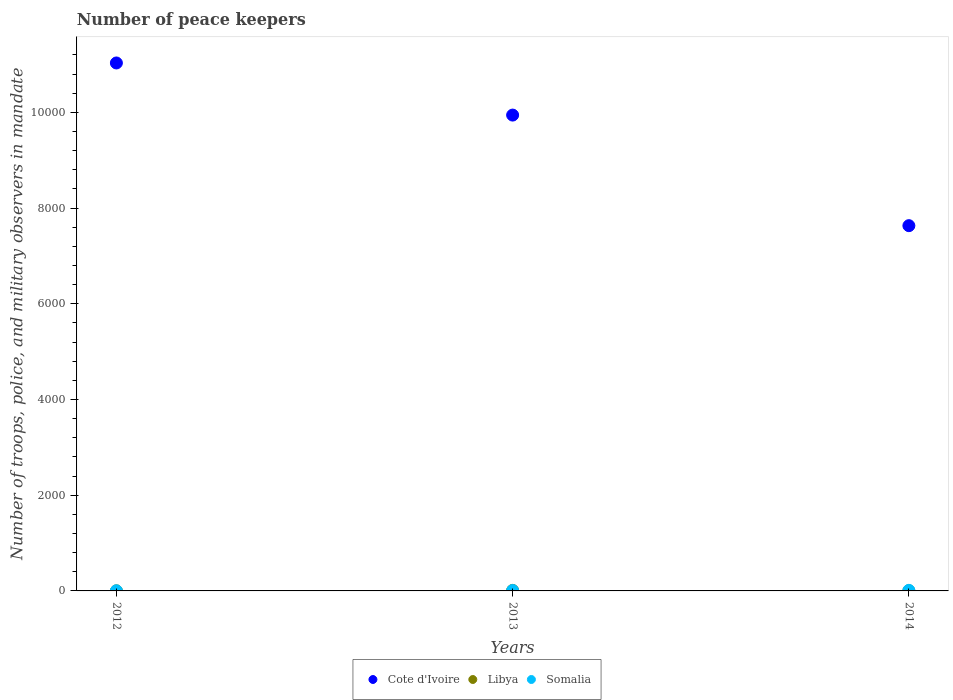Is the number of dotlines equal to the number of legend labels?
Give a very brief answer. Yes. What is the number of peace keepers in in Cote d'Ivoire in 2014?
Make the answer very short. 7633. Across all years, what is the maximum number of peace keepers in in Libya?
Provide a succinct answer. 11. What is the total number of peace keepers in in Cote d'Ivoire in the graph?
Provide a succinct answer. 2.86e+04. What is the difference between the number of peace keepers in in Somalia in 2013 and the number of peace keepers in in Cote d'Ivoire in 2012?
Provide a succinct answer. -1.10e+04. What is the average number of peace keepers in in Libya per year?
Your response must be concise. 5. In how many years, is the number of peace keepers in in Somalia greater than 10000?
Offer a very short reply. 0. Is the number of peace keepers in in Somalia in 2012 less than that in 2014?
Ensure brevity in your answer.  Yes. What is the difference between the highest and the second highest number of peace keepers in in Cote d'Ivoire?
Give a very brief answer. 1089. What is the difference between the highest and the lowest number of peace keepers in in Cote d'Ivoire?
Provide a short and direct response. 3400. Is the sum of the number of peace keepers in in Somalia in 2013 and 2014 greater than the maximum number of peace keepers in in Cote d'Ivoire across all years?
Your answer should be very brief. No. Is the number of peace keepers in in Cote d'Ivoire strictly greater than the number of peace keepers in in Libya over the years?
Offer a very short reply. Yes. Is the number of peace keepers in in Somalia strictly less than the number of peace keepers in in Cote d'Ivoire over the years?
Provide a short and direct response. Yes. How many dotlines are there?
Offer a terse response. 3. How many legend labels are there?
Your answer should be compact. 3. How are the legend labels stacked?
Offer a very short reply. Horizontal. What is the title of the graph?
Provide a short and direct response. Number of peace keepers. Does "Euro area" appear as one of the legend labels in the graph?
Offer a terse response. No. What is the label or title of the Y-axis?
Your answer should be very brief. Number of troops, police, and military observers in mandate. What is the Number of troops, police, and military observers in mandate of Cote d'Ivoire in 2012?
Make the answer very short. 1.10e+04. What is the Number of troops, police, and military observers in mandate in Libya in 2012?
Provide a short and direct response. 2. What is the Number of troops, police, and military observers in mandate in Somalia in 2012?
Your response must be concise. 3. What is the Number of troops, police, and military observers in mandate of Cote d'Ivoire in 2013?
Give a very brief answer. 9944. What is the Number of troops, police, and military observers in mandate of Cote d'Ivoire in 2014?
Your response must be concise. 7633. What is the Number of troops, police, and military observers in mandate of Libya in 2014?
Make the answer very short. 2. Across all years, what is the maximum Number of troops, police, and military observers in mandate of Cote d'Ivoire?
Offer a terse response. 1.10e+04. Across all years, what is the maximum Number of troops, police, and military observers in mandate in Somalia?
Your answer should be compact. 12. Across all years, what is the minimum Number of troops, police, and military observers in mandate of Cote d'Ivoire?
Your answer should be compact. 7633. Across all years, what is the minimum Number of troops, police, and military observers in mandate of Libya?
Your response must be concise. 2. Across all years, what is the minimum Number of troops, police, and military observers in mandate in Somalia?
Make the answer very short. 3. What is the total Number of troops, police, and military observers in mandate of Cote d'Ivoire in the graph?
Your response must be concise. 2.86e+04. What is the total Number of troops, police, and military observers in mandate of Libya in the graph?
Your response must be concise. 15. What is the total Number of troops, police, and military observers in mandate in Somalia in the graph?
Keep it short and to the point. 24. What is the difference between the Number of troops, police, and military observers in mandate in Cote d'Ivoire in 2012 and that in 2013?
Your response must be concise. 1089. What is the difference between the Number of troops, police, and military observers in mandate of Libya in 2012 and that in 2013?
Your answer should be compact. -9. What is the difference between the Number of troops, police, and military observers in mandate in Somalia in 2012 and that in 2013?
Offer a terse response. -6. What is the difference between the Number of troops, police, and military observers in mandate in Cote d'Ivoire in 2012 and that in 2014?
Offer a terse response. 3400. What is the difference between the Number of troops, police, and military observers in mandate in Libya in 2012 and that in 2014?
Keep it short and to the point. 0. What is the difference between the Number of troops, police, and military observers in mandate in Somalia in 2012 and that in 2014?
Your answer should be compact. -9. What is the difference between the Number of troops, police, and military observers in mandate in Cote d'Ivoire in 2013 and that in 2014?
Provide a short and direct response. 2311. What is the difference between the Number of troops, police, and military observers in mandate in Cote d'Ivoire in 2012 and the Number of troops, police, and military observers in mandate in Libya in 2013?
Offer a very short reply. 1.10e+04. What is the difference between the Number of troops, police, and military observers in mandate of Cote d'Ivoire in 2012 and the Number of troops, police, and military observers in mandate of Somalia in 2013?
Keep it short and to the point. 1.10e+04. What is the difference between the Number of troops, police, and military observers in mandate of Cote d'Ivoire in 2012 and the Number of troops, police, and military observers in mandate of Libya in 2014?
Provide a short and direct response. 1.10e+04. What is the difference between the Number of troops, police, and military observers in mandate in Cote d'Ivoire in 2012 and the Number of troops, police, and military observers in mandate in Somalia in 2014?
Your response must be concise. 1.10e+04. What is the difference between the Number of troops, police, and military observers in mandate in Cote d'Ivoire in 2013 and the Number of troops, police, and military observers in mandate in Libya in 2014?
Your answer should be compact. 9942. What is the difference between the Number of troops, police, and military observers in mandate of Cote d'Ivoire in 2013 and the Number of troops, police, and military observers in mandate of Somalia in 2014?
Your answer should be very brief. 9932. What is the difference between the Number of troops, police, and military observers in mandate of Libya in 2013 and the Number of troops, police, and military observers in mandate of Somalia in 2014?
Ensure brevity in your answer.  -1. What is the average Number of troops, police, and military observers in mandate in Cote d'Ivoire per year?
Offer a very short reply. 9536.67. In the year 2012, what is the difference between the Number of troops, police, and military observers in mandate of Cote d'Ivoire and Number of troops, police, and military observers in mandate of Libya?
Ensure brevity in your answer.  1.10e+04. In the year 2012, what is the difference between the Number of troops, police, and military observers in mandate in Cote d'Ivoire and Number of troops, police, and military observers in mandate in Somalia?
Offer a very short reply. 1.10e+04. In the year 2013, what is the difference between the Number of troops, police, and military observers in mandate in Cote d'Ivoire and Number of troops, police, and military observers in mandate in Libya?
Make the answer very short. 9933. In the year 2013, what is the difference between the Number of troops, police, and military observers in mandate of Cote d'Ivoire and Number of troops, police, and military observers in mandate of Somalia?
Keep it short and to the point. 9935. In the year 2014, what is the difference between the Number of troops, police, and military observers in mandate in Cote d'Ivoire and Number of troops, police, and military observers in mandate in Libya?
Offer a very short reply. 7631. In the year 2014, what is the difference between the Number of troops, police, and military observers in mandate of Cote d'Ivoire and Number of troops, police, and military observers in mandate of Somalia?
Make the answer very short. 7621. In the year 2014, what is the difference between the Number of troops, police, and military observers in mandate in Libya and Number of troops, police, and military observers in mandate in Somalia?
Offer a very short reply. -10. What is the ratio of the Number of troops, police, and military observers in mandate of Cote d'Ivoire in 2012 to that in 2013?
Offer a very short reply. 1.11. What is the ratio of the Number of troops, police, and military observers in mandate of Libya in 2012 to that in 2013?
Offer a very short reply. 0.18. What is the ratio of the Number of troops, police, and military observers in mandate of Somalia in 2012 to that in 2013?
Your answer should be compact. 0.33. What is the ratio of the Number of troops, police, and military observers in mandate in Cote d'Ivoire in 2012 to that in 2014?
Your response must be concise. 1.45. What is the ratio of the Number of troops, police, and military observers in mandate of Libya in 2012 to that in 2014?
Offer a terse response. 1. What is the ratio of the Number of troops, police, and military observers in mandate of Cote d'Ivoire in 2013 to that in 2014?
Make the answer very short. 1.3. What is the ratio of the Number of troops, police, and military observers in mandate of Libya in 2013 to that in 2014?
Your response must be concise. 5.5. What is the ratio of the Number of troops, police, and military observers in mandate of Somalia in 2013 to that in 2014?
Your answer should be very brief. 0.75. What is the difference between the highest and the second highest Number of troops, police, and military observers in mandate in Cote d'Ivoire?
Keep it short and to the point. 1089. What is the difference between the highest and the lowest Number of troops, police, and military observers in mandate in Cote d'Ivoire?
Give a very brief answer. 3400. What is the difference between the highest and the lowest Number of troops, police, and military observers in mandate of Libya?
Offer a terse response. 9. What is the difference between the highest and the lowest Number of troops, police, and military observers in mandate in Somalia?
Give a very brief answer. 9. 